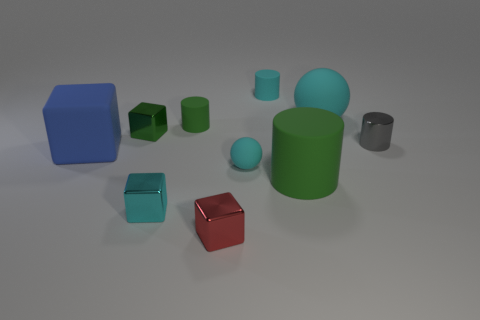Subtract all purple blocks. Subtract all cyan cylinders. How many blocks are left? 4 Subtract all cubes. How many objects are left? 6 Add 2 small cyan shiny cubes. How many small cyan shiny cubes exist? 3 Subtract 1 red cubes. How many objects are left? 9 Subtract all big yellow shiny blocks. Subtract all gray metallic objects. How many objects are left? 9 Add 4 big cyan rubber things. How many big cyan rubber things are left? 5 